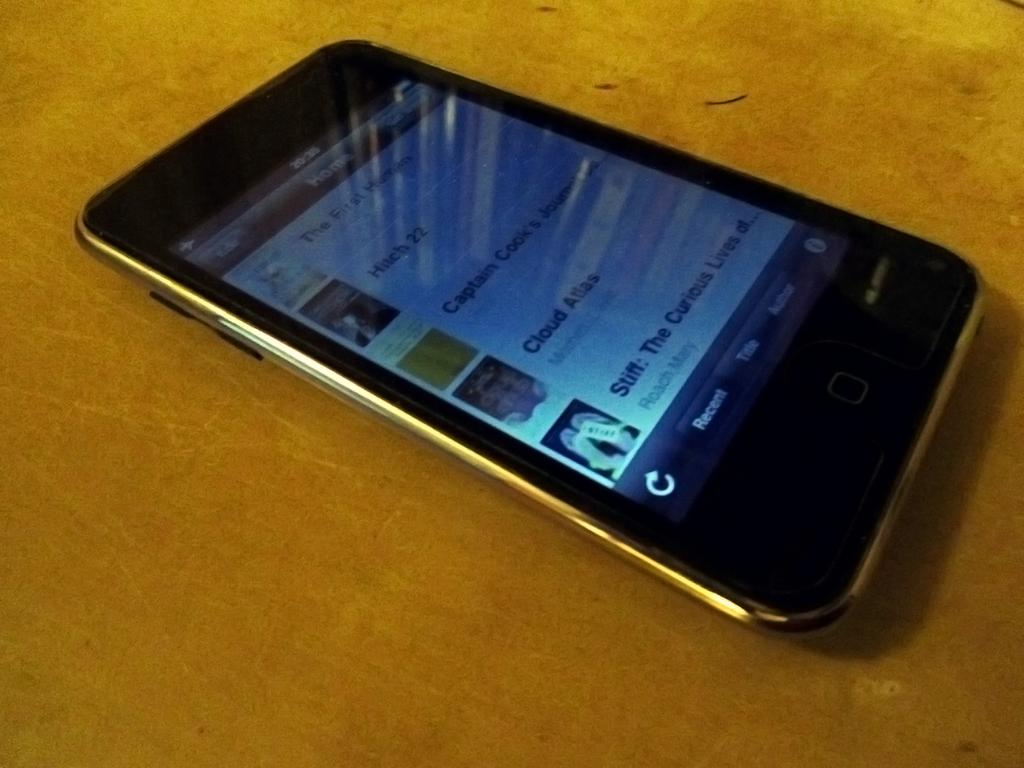<image>
Create a compact narrative representing the image presented. An Ipod with movie or song icons, including Hitch 22 and  Cloud Atlas is displayed on a table. 